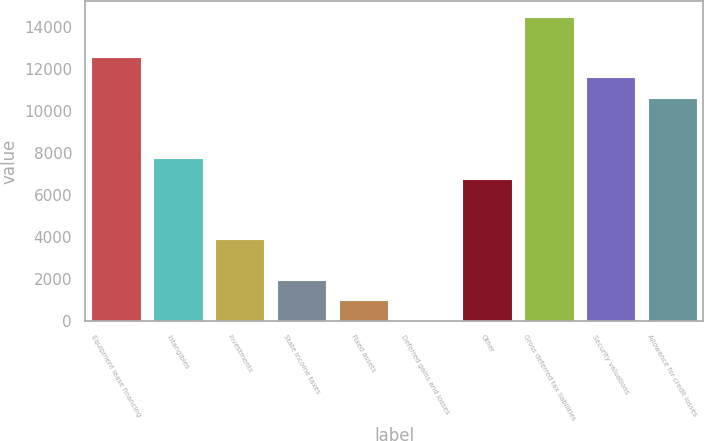Convert chart. <chart><loc_0><loc_0><loc_500><loc_500><bar_chart><fcel>Equipment lease financing<fcel>Intangibles<fcel>Investments<fcel>State income taxes<fcel>Fixed assets<fcel>Deferred gains and losses<fcel>Other<fcel>Gross deferred tax liabilities<fcel>Security valuations<fcel>Allowance for credit losses<nl><fcel>12565.2<fcel>7738.2<fcel>3876.6<fcel>1945.8<fcel>980.4<fcel>15<fcel>6772.8<fcel>14496<fcel>11599.8<fcel>10634.4<nl></chart> 